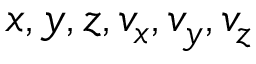<formula> <loc_0><loc_0><loc_500><loc_500>x , y , z , v _ { x } , v _ { y } , v _ { z }</formula> 